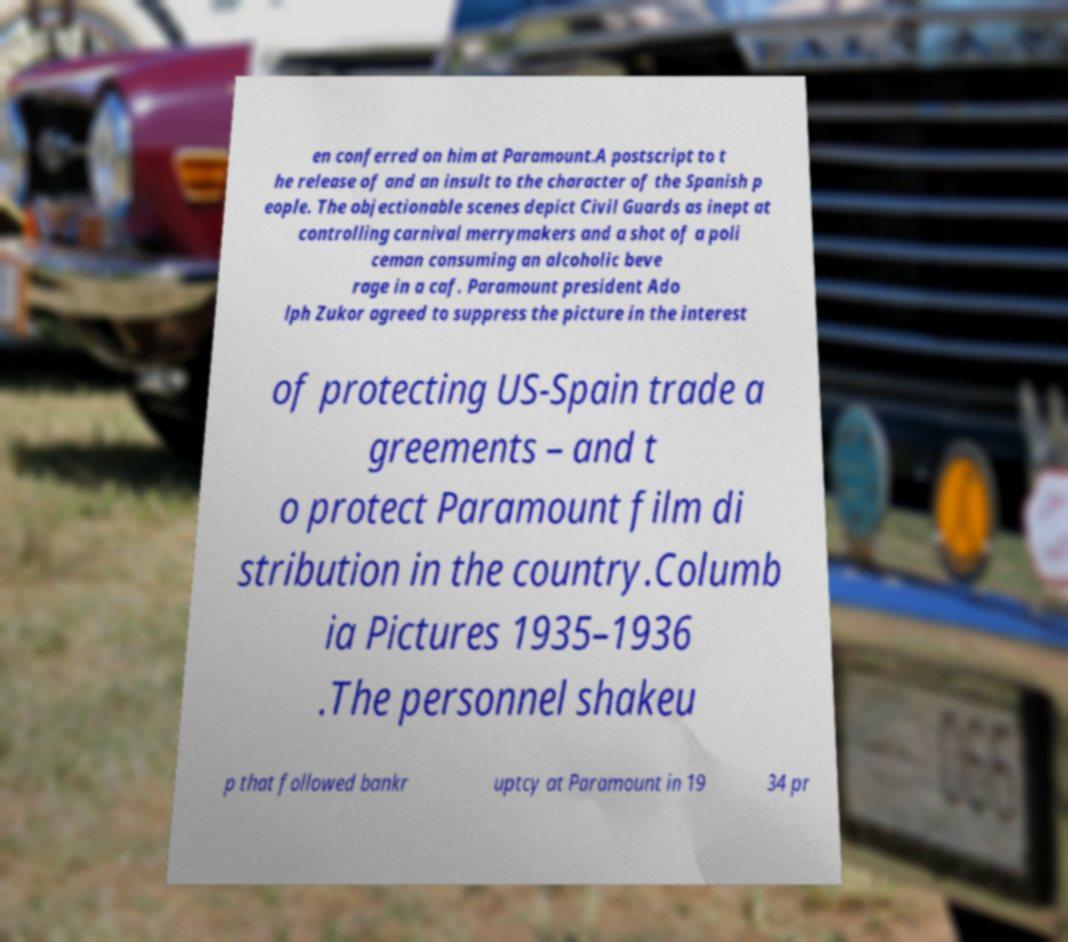Could you extract and type out the text from this image? en conferred on him at Paramount.A postscript to t he release of and an insult to the character of the Spanish p eople. The objectionable scenes depict Civil Guards as inept at controlling carnival merrymakers and a shot of a poli ceman consuming an alcoholic beve rage in a caf. Paramount president Ado lph Zukor agreed to suppress the picture in the interest of protecting US-Spain trade a greements – and t o protect Paramount film di stribution in the country.Columb ia Pictures 1935–1936 .The personnel shakeu p that followed bankr uptcy at Paramount in 19 34 pr 